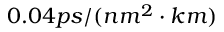Convert formula to latex. <formula><loc_0><loc_0><loc_500><loc_500>0 . 0 4 p s / ( n m ^ { 2 } \cdot k m )</formula> 